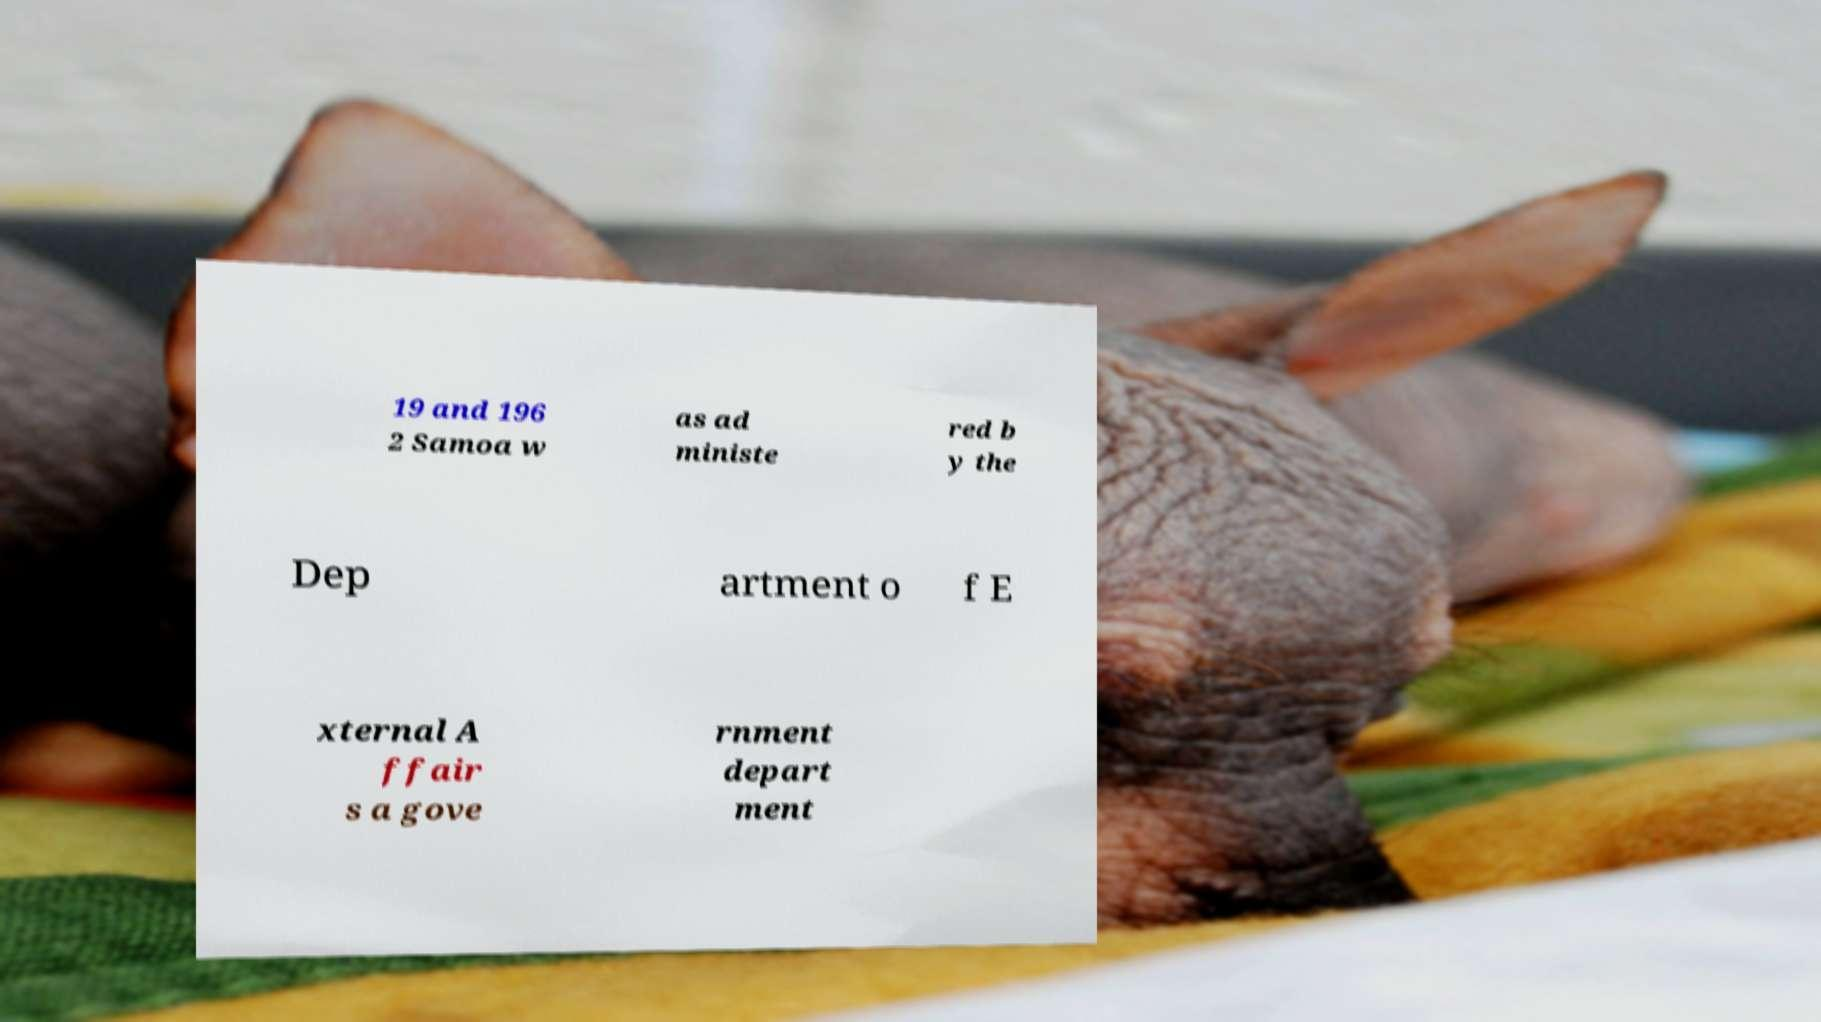There's text embedded in this image that I need extracted. Can you transcribe it verbatim? 19 and 196 2 Samoa w as ad ministe red b y the Dep artment o f E xternal A ffair s a gove rnment depart ment 